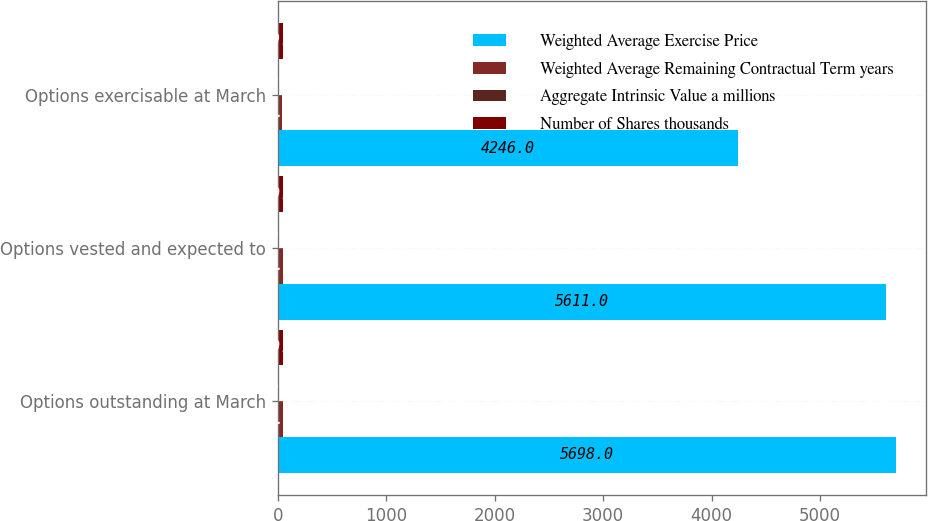Convert chart to OTSL. <chart><loc_0><loc_0><loc_500><loc_500><stacked_bar_chart><ecel><fcel>Options outstanding at March<fcel>Options vested and expected to<fcel>Options exercisable at March<nl><fcel>Weighted Average Exercise Price<fcel>5698<fcel>5611<fcel>4246<nl><fcel>Weighted Average Remaining Contractual Term years<fcel>44.22<fcel>43.97<fcel>36.22<nl><fcel>Aggregate Intrinsic Value a millions<fcel>4.8<fcel>4.8<fcel>4.4<nl><fcel>Number of Shares thousands<fcel>50<fcel>50<fcel>49.9<nl></chart> 